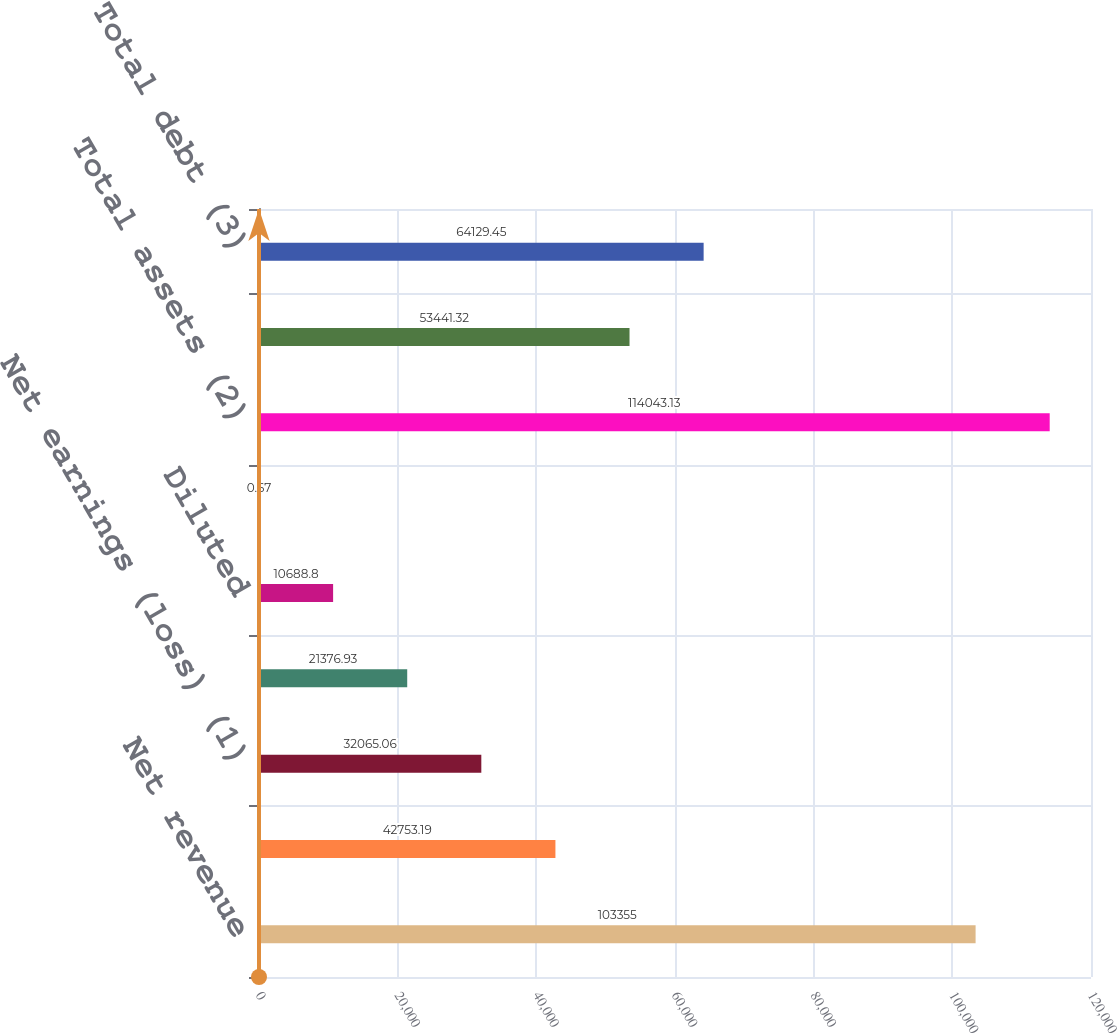Convert chart to OTSL. <chart><loc_0><loc_0><loc_500><loc_500><bar_chart><fcel>Net revenue<fcel>Earnings (loss) from<fcel>Net earnings (loss) (1)<fcel>Basic<fcel>Diluted<fcel>Cash dividends declared per<fcel>Total assets (2)<fcel>Long-term debt<fcel>Total debt (3)<nl><fcel>103355<fcel>42753.2<fcel>32065.1<fcel>21376.9<fcel>10688.8<fcel>0.67<fcel>114043<fcel>53441.3<fcel>64129.4<nl></chart> 